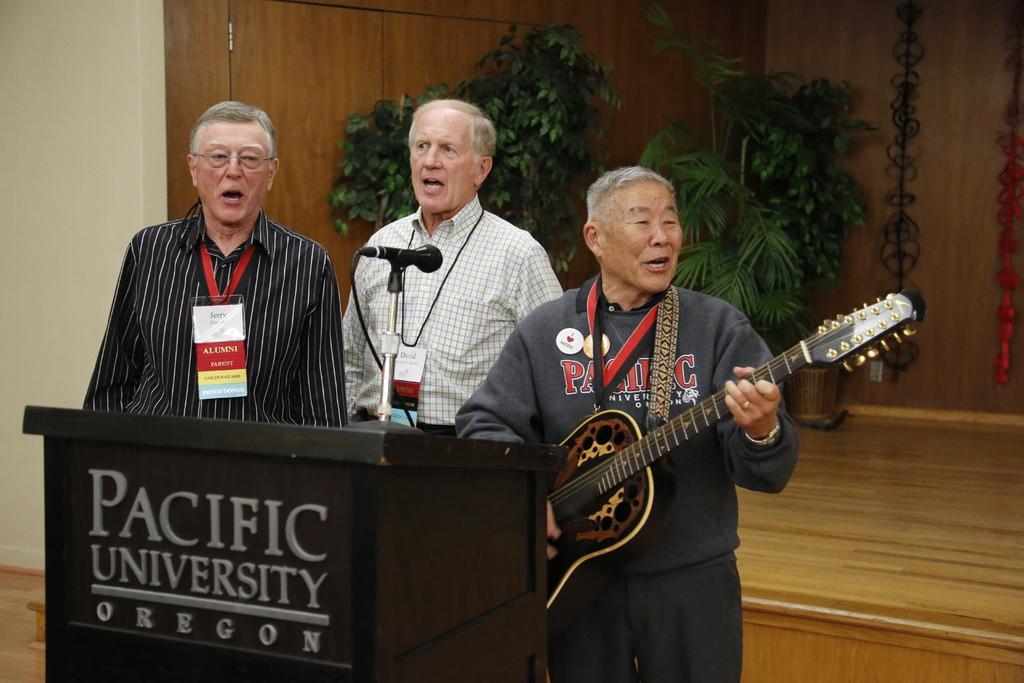Can you describe this image briefly? In this picture, there are three people standing and singing in front of a podium on which we see a micro microphone. Man who is wearing grey jacket is holding guitar in his hands and playing it. Men in blue shirt is wearing ID card. Behind them, we see cupboard which is brown in color and we even see trees. 